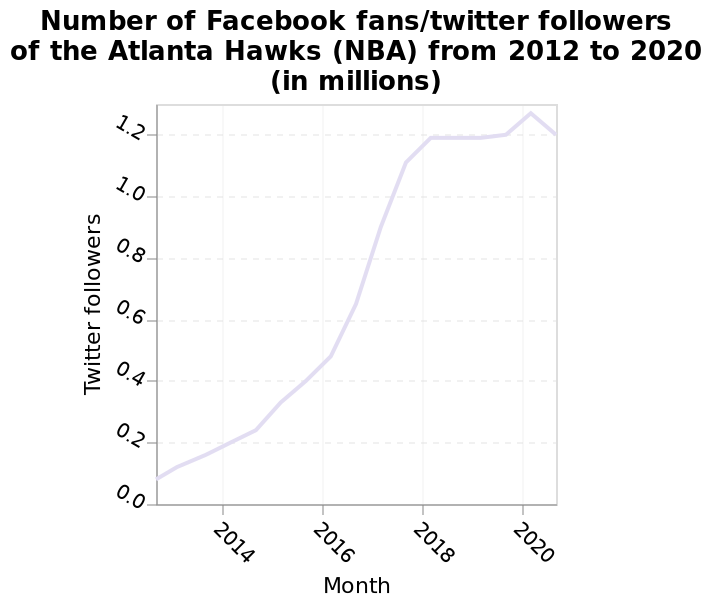<image>
Describe the following image in detail Number of Facebook fans/twitter followers of the Atlanta Hawks (NBA) from 2012 to 2020 (in millions) is a line graph. There is a linear scale with a minimum of 2014 and a maximum of 2020 on the x-axis, labeled Month. The y-axis plots Twitter followers. Offer a thorough analysis of the image. The number of Facebook fans/twitter followers of the Atlanta Hawks increased between the years 2010 to 2018. The number of Facebook fans/twitter followers of the Atlanta Hawks increased less between the years 2018 and 2020 than between the years 2010 to 2018. In 2020 the number of Facebook fans/twitter followers of the Atlanta Hawk reached its highest number - over 1.2 million. Also in 2020 the number of Facebook fans/twitter followers of the Atlanta Hawks fell for the first time between the years 2010 and 2020. There are signs of a fall in the number of Facebook fans/twitter followers in 2020. Are there signs of a fall in the number of Facebook fans/twitter followers of the Atlanta Hawks in 2020? Yes, there are signs of a fall in the number of Facebook fans/twitter followers of the Atlanta Hawks in 2020. 